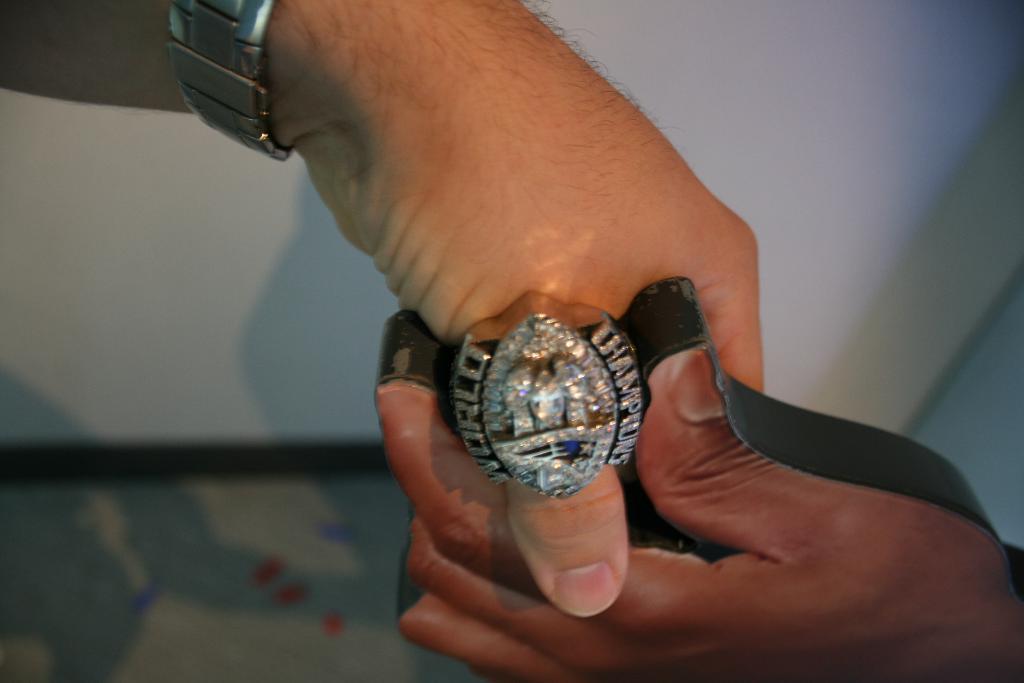Is this a world championship ring?
Your answer should be very brief. Yes. What does the ring say?
Your response must be concise. World champions. 